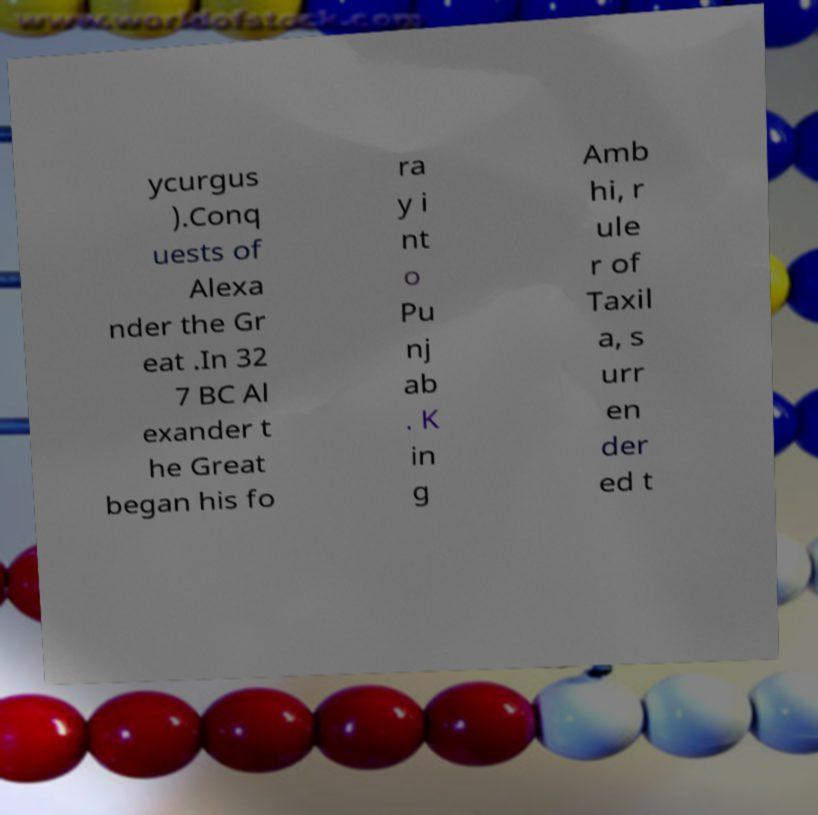Could you extract and type out the text from this image? ycurgus ).Conq uests of Alexa nder the Gr eat .In 32 7 BC Al exander t he Great began his fo ra y i nt o Pu nj ab . K in g Amb hi, r ule r of Taxil a, s urr en der ed t 